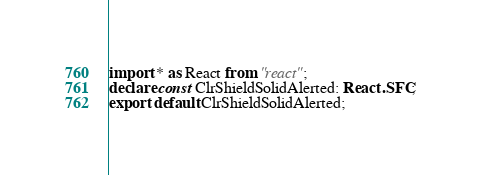Convert code to text. <code><loc_0><loc_0><loc_500><loc_500><_TypeScript_>import * as React from "react";
declare const ClrShieldSolidAlerted: React.SFC;
export default ClrShieldSolidAlerted;
</code> 